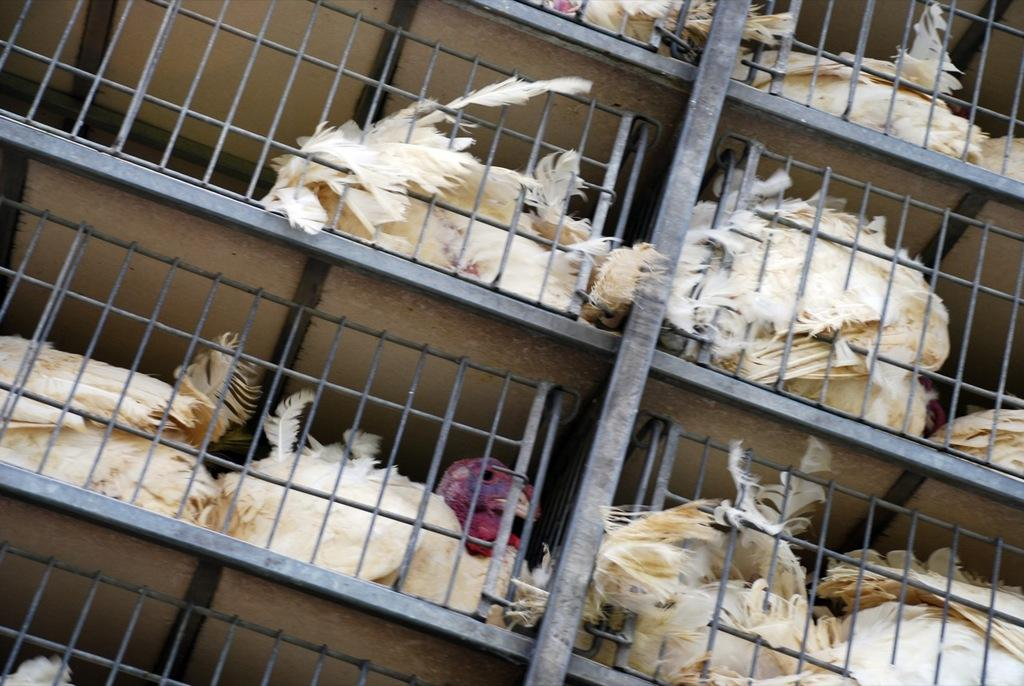What type of animals are present in the image? There are hens in the image. Where are the hens located? The hens are in poultry cages. What riddle does the hen attempt to solve in the image? There is no riddle present in the image, nor is there any indication that the hens are attempting to solve anything. 